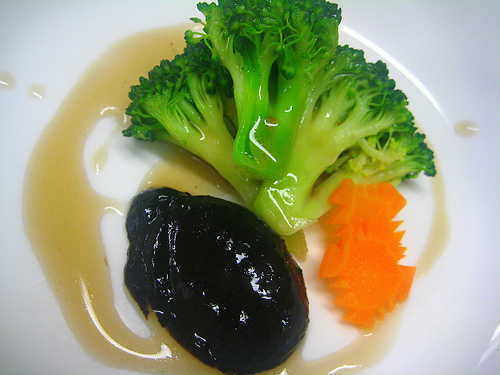Is there any significance to the way the food is arranged? Yes, the food is arranged with care, emphasizing a minimalist presentation. The broccoli is set pointing upwards, the black food item is centered, and the carrot slices are neatly arranged, which could indicate an emphasis on aesthetics and deliberate portion control. Could the colors of the food have some sort of symbolic meaning? The colors — green broccoli, orange carrot, and the darkness of the main item and sauce — may not necessarily have a symbolic meaning but rather are chosen for their visual contrast and ability to create an appealing and balanced presentation. 